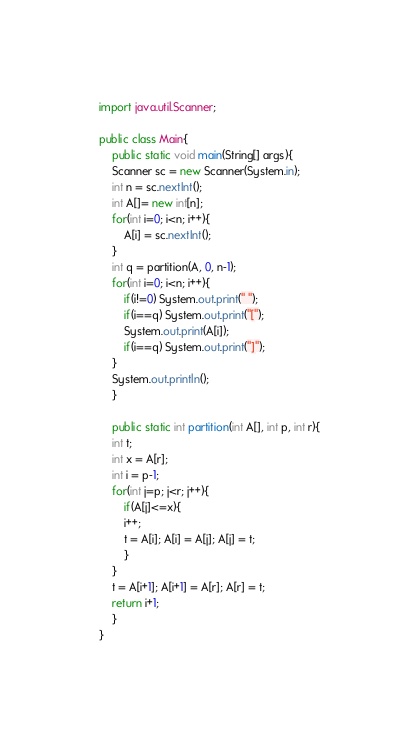Convert code to text. <code><loc_0><loc_0><loc_500><loc_500><_Java_>import java.util.Scanner;

public class Main{
    public static void main(String[] args){
    Scanner sc = new Scanner(System.in);
    int n = sc.nextInt();
    int A[]= new int[n];
    for(int i=0; i<n; i++){
        A[i] = sc.nextInt();
    }
    int q = partition(A, 0, n-1);
    for(int i=0; i<n; i++){
        if(i!=0) System.out.print(" ");
        if(i==q) System.out.print("[");
        System.out.print(A[i]);
        if(i==q) System.out.print("]");
    }
    System.out.println();
    }
     
    public static int partition(int A[], int p, int r){
    int t;
    int x = A[r];
    int i = p-1;
    for(int j=p; j<r; j++){
        if(A[j]<=x){
        i++;
        t = A[i]; A[i] = A[j]; A[j] = t;
        }
    }
    t = A[i+1]; A[i+1] = A[r]; A[r] = t;
    return i+1;
    }
}</code> 